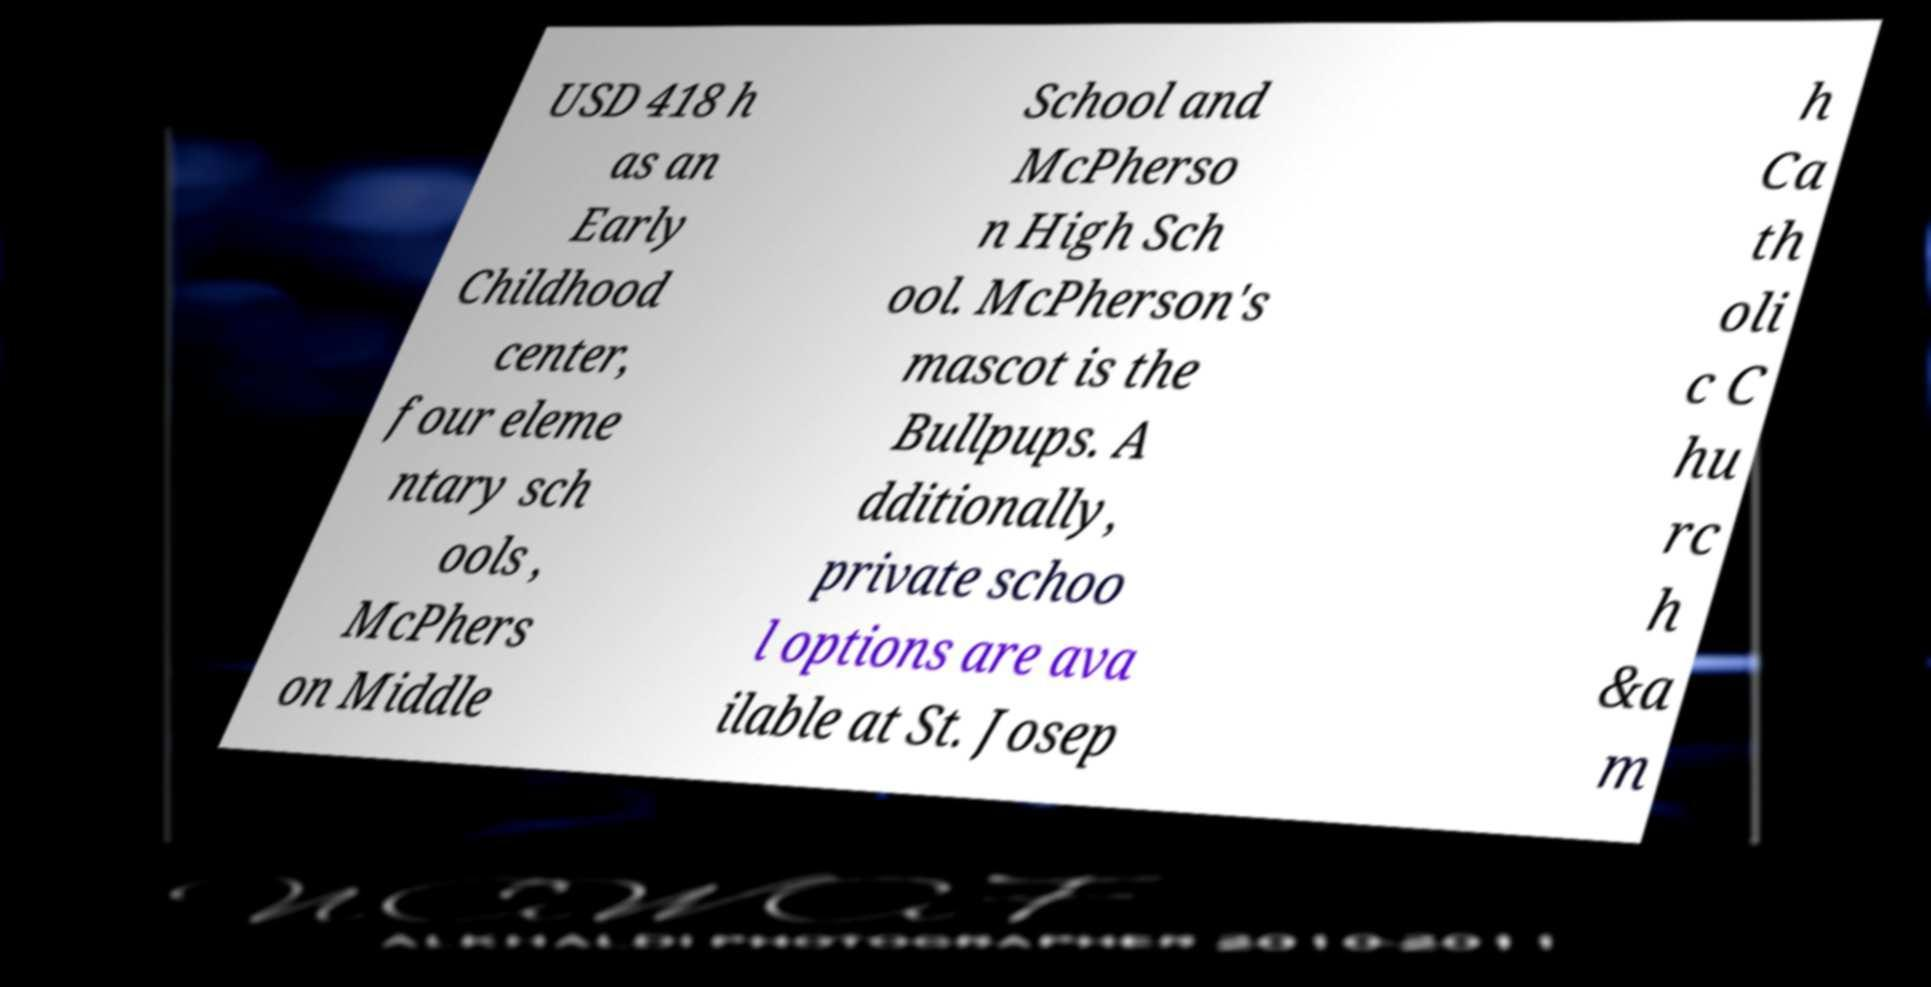Could you extract and type out the text from this image? USD 418 h as an Early Childhood center, four eleme ntary sch ools , McPhers on Middle School and McPherso n High Sch ool. McPherson's mascot is the Bullpups. A dditionally, private schoo l options are ava ilable at St. Josep h Ca th oli c C hu rc h &a m 